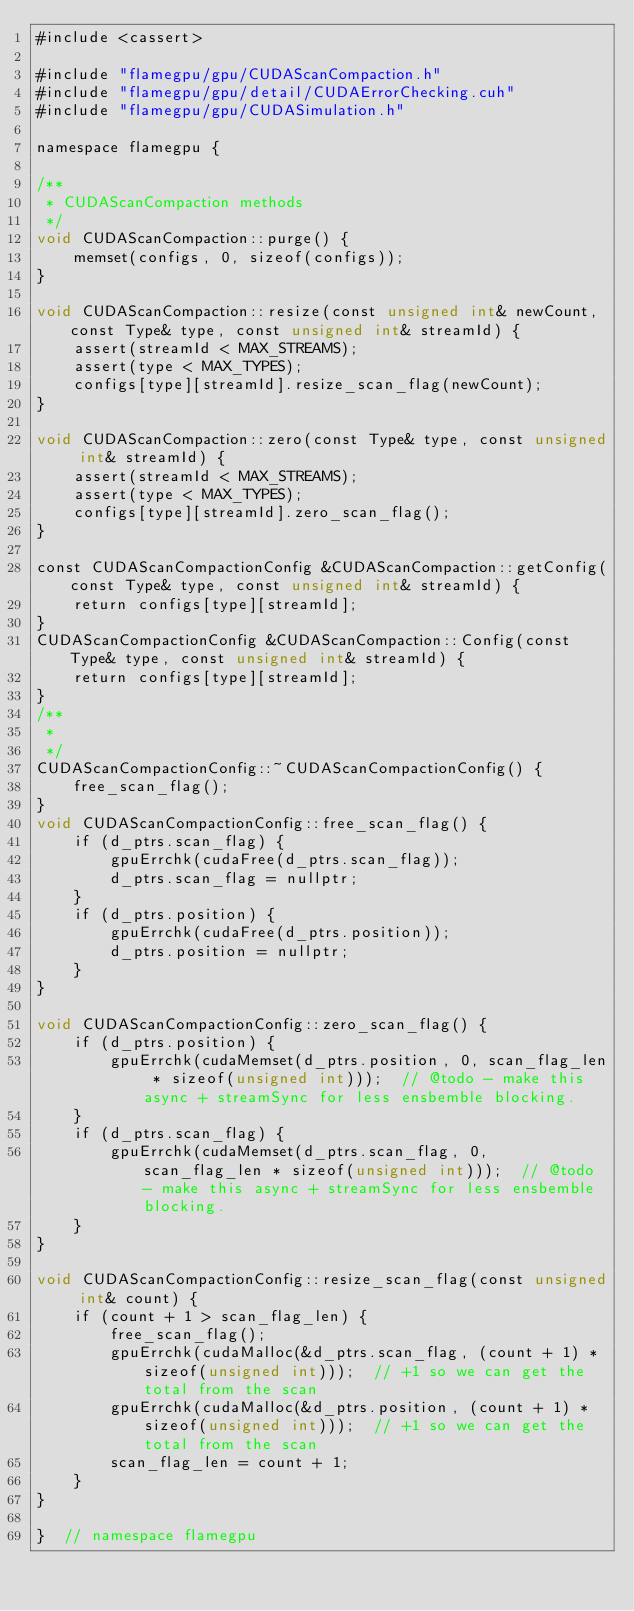Convert code to text. <code><loc_0><loc_0><loc_500><loc_500><_Cuda_>#include <cassert>

#include "flamegpu/gpu/CUDAScanCompaction.h"
#include "flamegpu/gpu/detail/CUDAErrorChecking.cuh"
#include "flamegpu/gpu/CUDASimulation.h"

namespace flamegpu {

/**
 * CUDAScanCompaction methods
 */
void CUDAScanCompaction::purge() {
    memset(configs, 0, sizeof(configs));
}

void CUDAScanCompaction::resize(const unsigned int& newCount, const Type& type, const unsigned int& streamId) {
    assert(streamId < MAX_STREAMS);
    assert(type < MAX_TYPES);
    configs[type][streamId].resize_scan_flag(newCount);
}

void CUDAScanCompaction::zero(const Type& type, const unsigned int& streamId) {
    assert(streamId < MAX_STREAMS);
    assert(type < MAX_TYPES);
    configs[type][streamId].zero_scan_flag();
}

const CUDAScanCompactionConfig &CUDAScanCompaction::getConfig(const Type& type, const unsigned int& streamId) {
    return configs[type][streamId];
}
CUDAScanCompactionConfig &CUDAScanCompaction::Config(const Type& type, const unsigned int& streamId) {
    return configs[type][streamId];
}
/**
 *
 */
CUDAScanCompactionConfig::~CUDAScanCompactionConfig() {
    free_scan_flag();
}
void CUDAScanCompactionConfig::free_scan_flag() {
    if (d_ptrs.scan_flag) {
        gpuErrchk(cudaFree(d_ptrs.scan_flag));
        d_ptrs.scan_flag = nullptr;
    }
    if (d_ptrs.position) {
        gpuErrchk(cudaFree(d_ptrs.position));
        d_ptrs.position = nullptr;
    }
}

void CUDAScanCompactionConfig::zero_scan_flag() {
    if (d_ptrs.position) {
        gpuErrchk(cudaMemset(d_ptrs.position, 0, scan_flag_len * sizeof(unsigned int)));  // @todo - make this async + streamSync for less ensbemble blocking.
    }
    if (d_ptrs.scan_flag) {
        gpuErrchk(cudaMemset(d_ptrs.scan_flag, 0, scan_flag_len * sizeof(unsigned int)));  // @todo - make this async + streamSync for less ensbemble blocking.
    }
}

void CUDAScanCompactionConfig::resize_scan_flag(const unsigned int& count) {
    if (count + 1 > scan_flag_len) {
        free_scan_flag();
        gpuErrchk(cudaMalloc(&d_ptrs.scan_flag, (count + 1) * sizeof(unsigned int)));  // +1 so we can get the total from the scan
        gpuErrchk(cudaMalloc(&d_ptrs.position, (count + 1) * sizeof(unsigned int)));  // +1 so we can get the total from the scan
        scan_flag_len = count + 1;
    }
}

}  // namespace flamegpu
</code> 